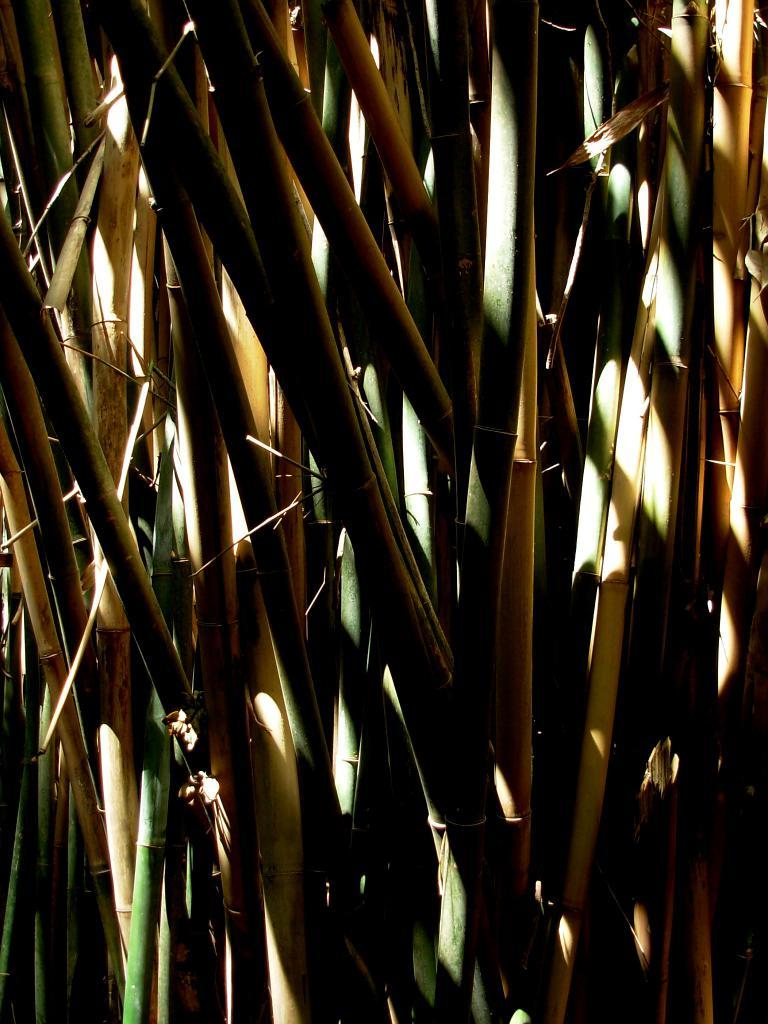What type of sticks are present in the image? There are bamboo sticks in the image. Can you describe the appearance of the bamboo sticks? The bamboo sticks are long and slender, with a smooth surface. What might the bamboo sticks be used for? Bamboo sticks can be used for various purposes, such as construction, cooking, or crafting. What color is the snow in the image? There is no snow present in the image; it features bamboo sticks. 